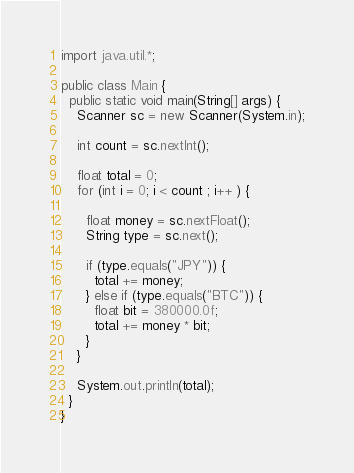<code> <loc_0><loc_0><loc_500><loc_500><_Java_>import java.util.*;

public class Main {
  public static void main(String[] args) {
    Scanner sc = new Scanner(System.in);

    int count = sc.nextInt();

    float total = 0;
    for (int i = 0; i < count ; i++ ) {

      float money = sc.nextFloat();
      String type = sc.next();

      if (type.equals("JPY")) {
        total += money;
      } else if (type.equals("BTC")) {
        float bit = 380000.0f;
        total += money * bit;
      }
    }

    System.out.println(total);
  }
}
</code> 